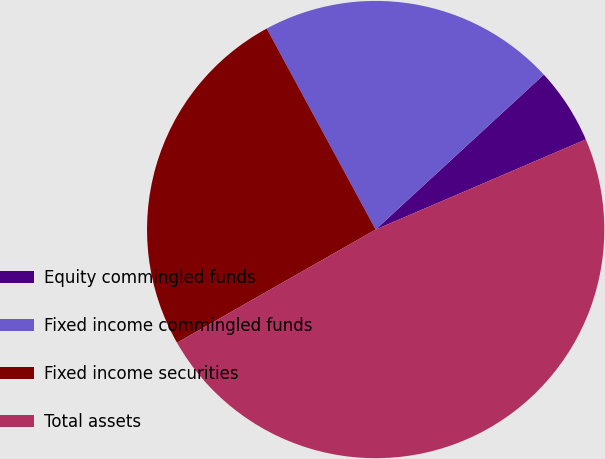Convert chart to OTSL. <chart><loc_0><loc_0><loc_500><loc_500><pie_chart><fcel>Equity commingled funds<fcel>Fixed income commingled funds<fcel>Fixed income securities<fcel>Total assets<nl><fcel>5.4%<fcel>21.06%<fcel>25.34%<fcel>48.21%<nl></chart> 